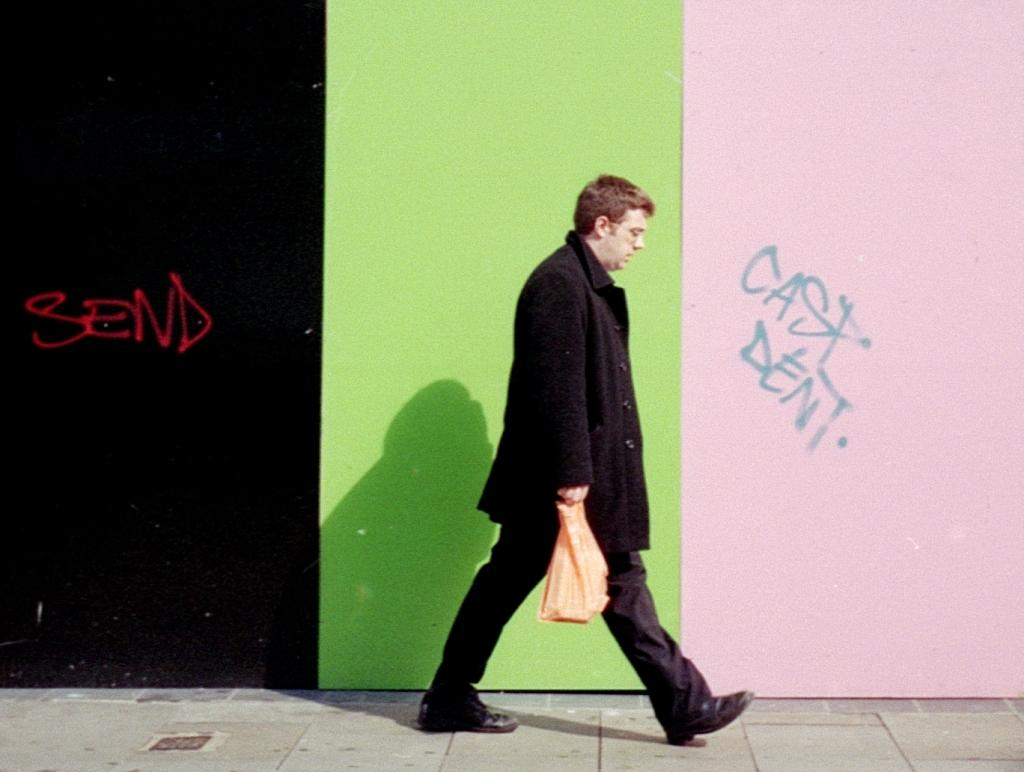What is the main subject of the image? There is a person walking in the image. What is the person holding? The person is holding something, but the specific object cannot be determined from the facts provided. Can you describe the background of the image? The background of the image has green, pink, and black colors. Is there any text or writing in the image? Yes, there is text or writing on the background. What type of bedroom can be seen in the image? There is no mention of a bedroom in the image. 